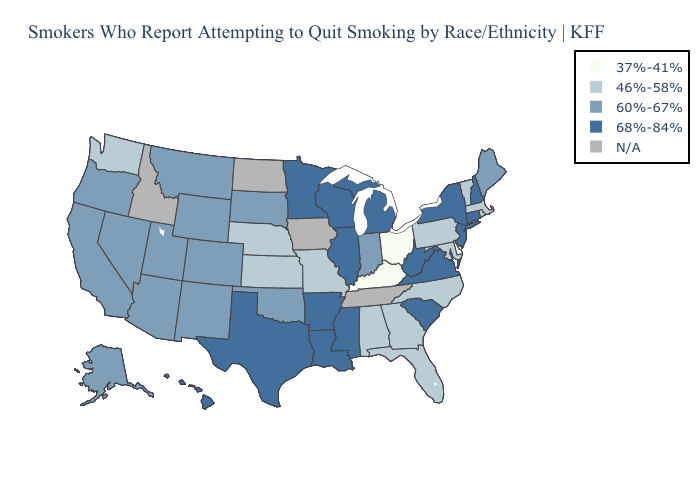Among the states that border Kentucky , does Virginia have the lowest value?
Short answer required. No. Does Missouri have the highest value in the MidWest?
Answer briefly. No. What is the highest value in the MidWest ?
Short answer required. 68%-84%. Which states have the lowest value in the South?
Answer briefly. Delaware, Kentucky. Name the states that have a value in the range 46%-58%?
Short answer required. Alabama, Florida, Georgia, Kansas, Maryland, Massachusetts, Missouri, Nebraska, North Carolina, Pennsylvania, Rhode Island, Vermont, Washington. Which states have the lowest value in the Northeast?
Concise answer only. Massachusetts, Pennsylvania, Rhode Island, Vermont. Name the states that have a value in the range 37%-41%?
Short answer required. Delaware, Kentucky, Ohio. What is the highest value in the West ?
Short answer required. 68%-84%. How many symbols are there in the legend?
Keep it brief. 5. Name the states that have a value in the range 60%-67%?
Short answer required. Alaska, Arizona, California, Colorado, Indiana, Maine, Montana, Nevada, New Mexico, Oklahoma, Oregon, South Dakota, Utah, Wyoming. Among the states that border Iowa , which have the highest value?
Concise answer only. Illinois, Minnesota, Wisconsin. Among the states that border Florida , which have the highest value?
Be succinct. Alabama, Georgia. Name the states that have a value in the range 46%-58%?
Short answer required. Alabama, Florida, Georgia, Kansas, Maryland, Massachusetts, Missouri, Nebraska, North Carolina, Pennsylvania, Rhode Island, Vermont, Washington. Which states have the highest value in the USA?
Keep it brief. Arkansas, Connecticut, Hawaii, Illinois, Louisiana, Michigan, Minnesota, Mississippi, New Hampshire, New Jersey, New York, South Carolina, Texas, Virginia, West Virginia, Wisconsin. What is the lowest value in the USA?
Short answer required. 37%-41%. 